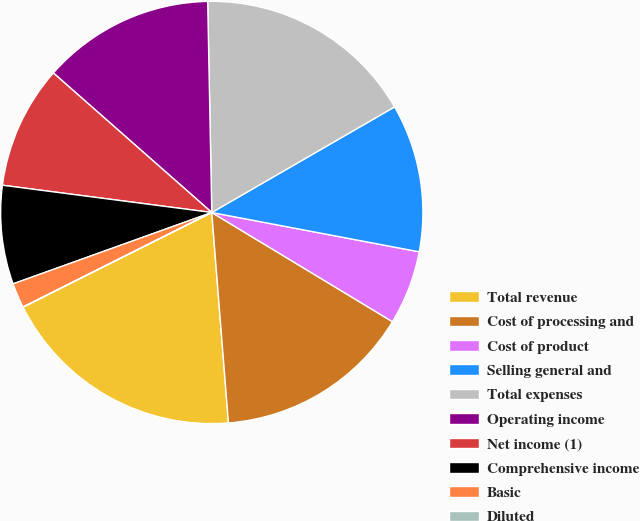Convert chart to OTSL. <chart><loc_0><loc_0><loc_500><loc_500><pie_chart><fcel>Total revenue<fcel>Cost of processing and<fcel>Cost of product<fcel>Selling general and<fcel>Total expenses<fcel>Operating income<fcel>Net income (1)<fcel>Comprehensive income<fcel>Basic<fcel>Diluted<nl><fcel>18.86%<fcel>15.09%<fcel>5.67%<fcel>11.32%<fcel>16.97%<fcel>13.2%<fcel>9.43%<fcel>7.55%<fcel>1.9%<fcel>0.01%<nl></chart> 